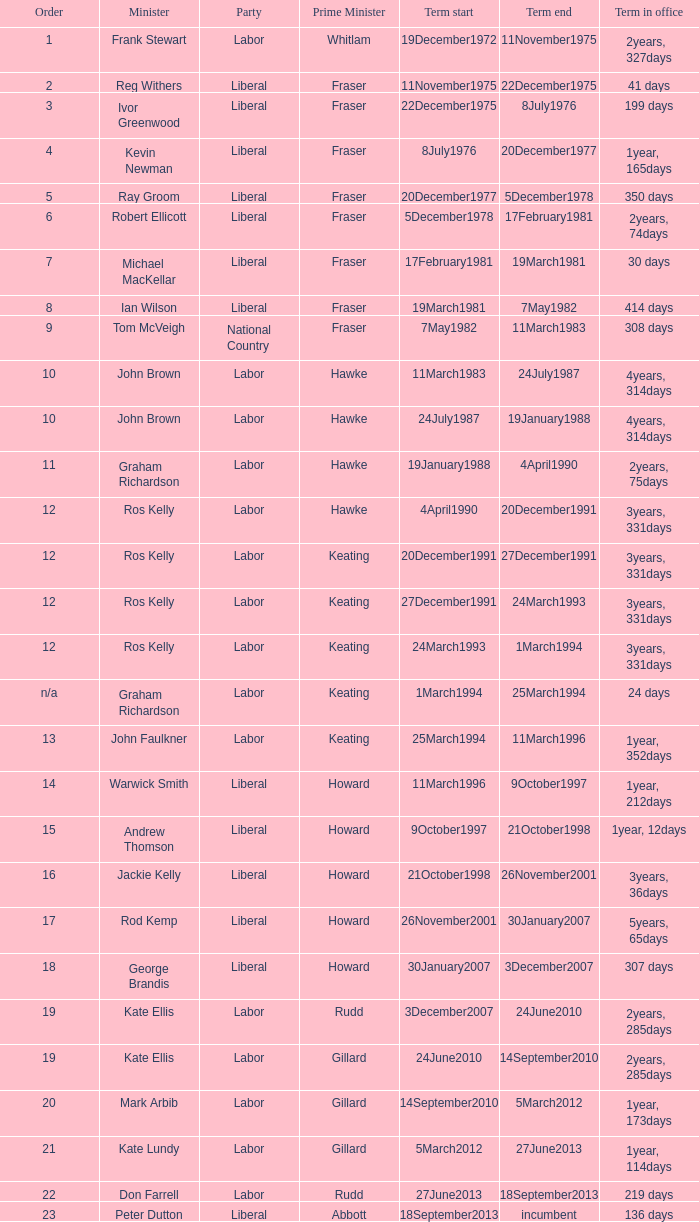Parse the table in full. {'header': ['Order', 'Minister', 'Party', 'Prime Minister', 'Term start', 'Term end', 'Term in office'], 'rows': [['1', 'Frank Stewart', 'Labor', 'Whitlam', '19December1972', '11November1975', '2years, 327days'], ['2', 'Reg Withers', 'Liberal', 'Fraser', '11November1975', '22December1975', '41 days'], ['3', 'Ivor Greenwood', 'Liberal', 'Fraser', '22December1975', '8July1976', '199 days'], ['4', 'Kevin Newman', 'Liberal', 'Fraser', '8July1976', '20December1977', '1year, 165days'], ['5', 'Ray Groom', 'Liberal', 'Fraser', '20December1977', '5December1978', '350 days'], ['6', 'Robert Ellicott', 'Liberal', 'Fraser', '5December1978', '17February1981', '2years, 74days'], ['7', 'Michael MacKellar', 'Liberal', 'Fraser', '17February1981', '19March1981', '30 days'], ['8', 'Ian Wilson', 'Liberal', 'Fraser', '19March1981', '7May1982', '414 days'], ['9', 'Tom McVeigh', 'National Country', 'Fraser', '7May1982', '11March1983', '308 days'], ['10', 'John Brown', 'Labor', 'Hawke', '11March1983', '24July1987', '4years, 314days'], ['10', 'John Brown', 'Labor', 'Hawke', '24July1987', '19January1988', '4years, 314days'], ['11', 'Graham Richardson', 'Labor', 'Hawke', '19January1988', '4April1990', '2years, 75days'], ['12', 'Ros Kelly', 'Labor', 'Hawke', '4April1990', '20December1991', '3years, 331days'], ['12', 'Ros Kelly', 'Labor', 'Keating', '20December1991', '27December1991', '3years, 331days'], ['12', 'Ros Kelly', 'Labor', 'Keating', '27December1991', '24March1993', '3years, 331days'], ['12', 'Ros Kelly', 'Labor', 'Keating', '24March1993', '1March1994', '3years, 331days'], ['n/a', 'Graham Richardson', 'Labor', 'Keating', '1March1994', '25March1994', '24 days'], ['13', 'John Faulkner', 'Labor', 'Keating', '25March1994', '11March1996', '1year, 352days'], ['14', 'Warwick Smith', 'Liberal', 'Howard', '11March1996', '9October1997', '1year, 212days'], ['15', 'Andrew Thomson', 'Liberal', 'Howard', '9October1997', '21October1998', '1year, 12days'], ['16', 'Jackie Kelly', 'Liberal', 'Howard', '21October1998', '26November2001', '3years, 36days'], ['17', 'Rod Kemp', 'Liberal', 'Howard', '26November2001', '30January2007', '5years, 65days'], ['18', 'George Brandis', 'Liberal', 'Howard', '30January2007', '3December2007', '307 days'], ['19', 'Kate Ellis', 'Labor', 'Rudd', '3December2007', '24June2010', '2years, 285days'], ['19', 'Kate Ellis', 'Labor', 'Gillard', '24June2010', '14September2010', '2years, 285days'], ['20', 'Mark Arbib', 'Labor', 'Gillard', '14September2010', '5March2012', '1year, 173days'], ['21', 'Kate Lundy', 'Labor', 'Gillard', '5March2012', '27June2013', '1year, 114days'], ['22', 'Don Farrell', 'Labor', 'Rudd', '27June2013', '18September2013', '219 days'], ['23', 'Peter Dutton', 'Liberal', 'Abbott', '18September2013', 'incumbent', '136 days']]} What is the tenure in office with a position that is 9? 308 days. 